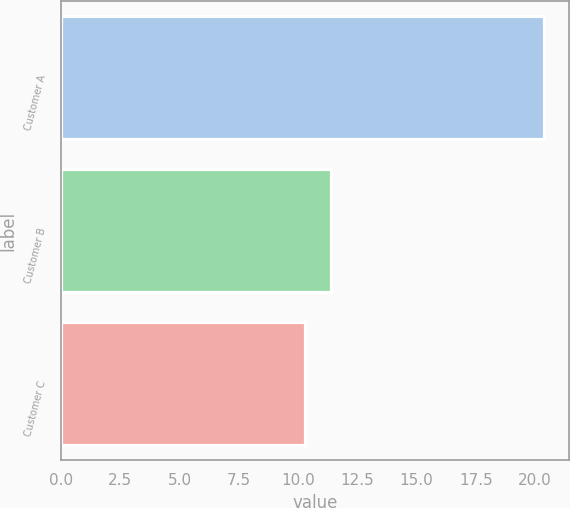Convert chart to OTSL. <chart><loc_0><loc_0><loc_500><loc_500><bar_chart><fcel>Customer A<fcel>Customer B<fcel>Customer C<nl><fcel>20.4<fcel>11.4<fcel>10.3<nl></chart> 